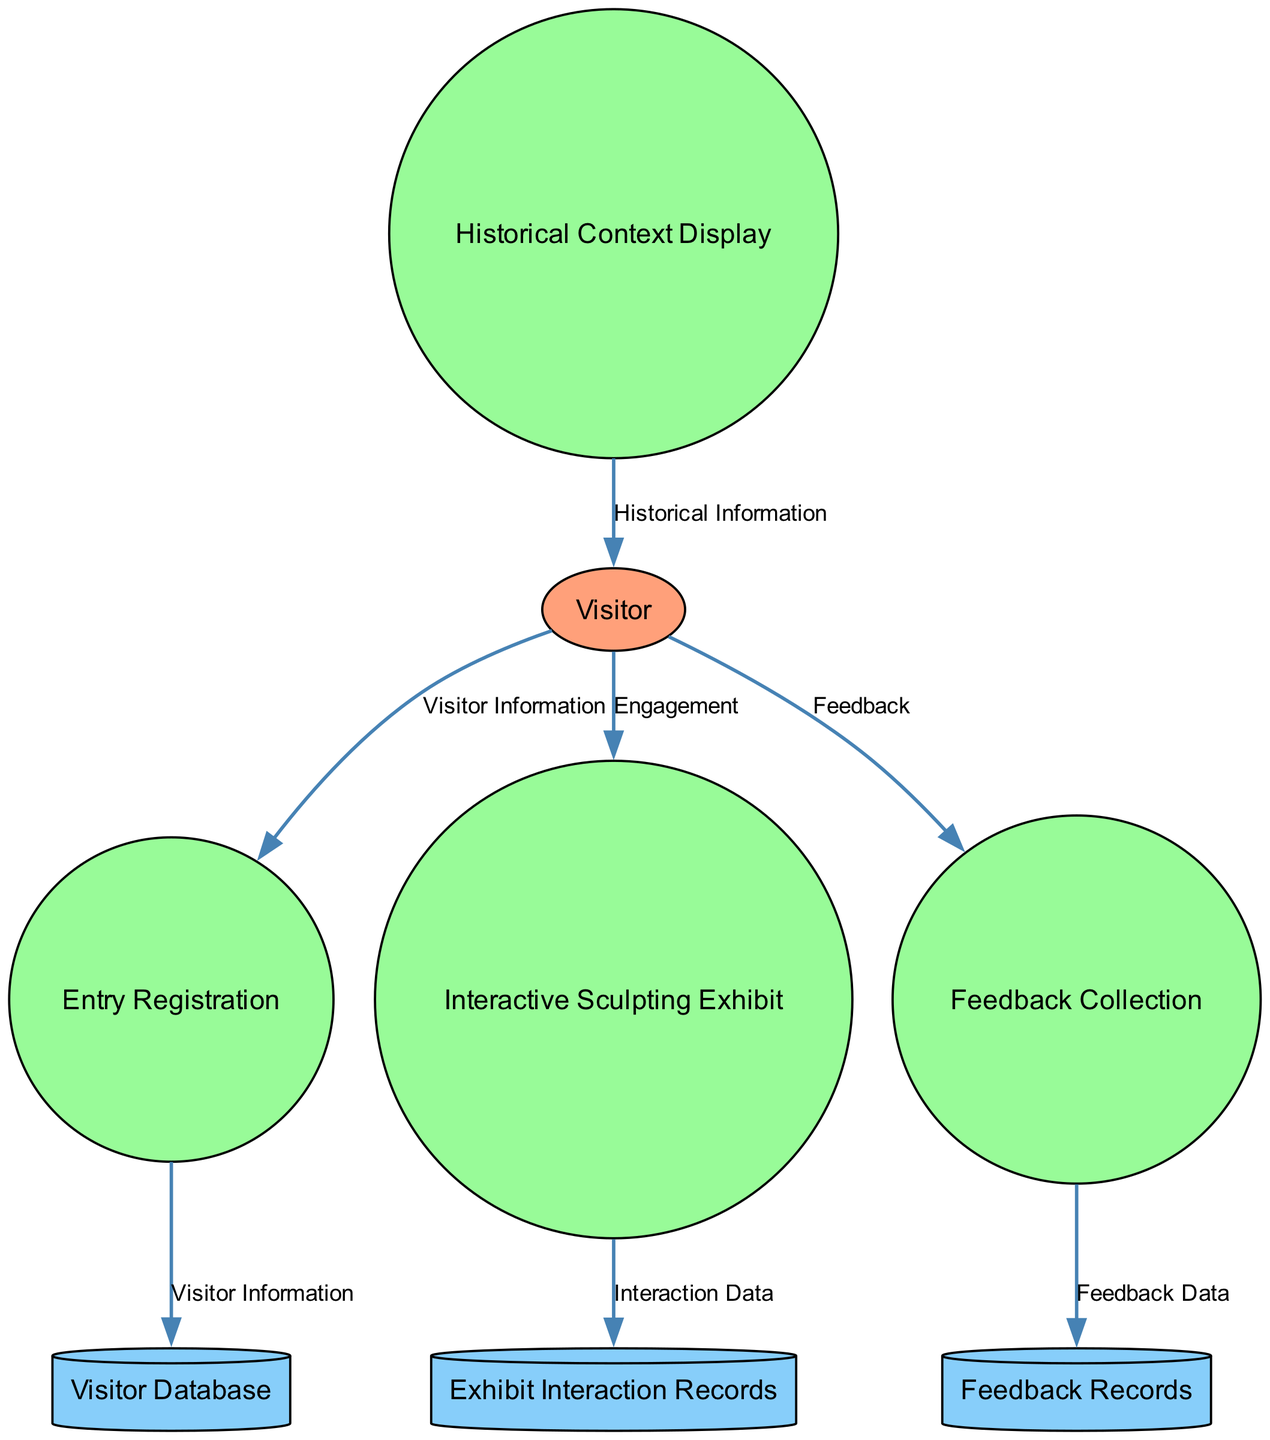What external entity is involved in this diagram? The diagram indicates "Visitor" as the external entity. It describes individuals who visit the museum for learning about ancient Greek sculptures and classical sculpting methods.
Answer: Visitor How many processes are depicted in this diagram? The diagram includes four processes: Entry Registration, Interactive Sculpting Exhibit, Historical Context Display, and Feedback Collection. Therefore, the total count of processes is four.
Answer: 4 What does the Interactive Sculpting Exhibit provide to visitors? The diagram shows that the Interactive Sculpting Exhibit allows visitors to engage in sculpting activities using virtual tools guided by classical methods.
Answer: Engagement From where does Feedback Data flow? According to the diagram, Feedback Data flows from Feedback Collection to Feedback Records, indicating that collected visitor feedback is stored in records.
Answer: Feedback Records Which data store contains visitor registration details? The Visitor Database is specified in the diagram as the data store for visitor registration details, including names, contact information, and ticket details.
Answer: Visitor Database What type of information does the Historical Context Display provide? The Historical Context Display provides Historical Information to visitors, offering context and background details about Greek sculptures and sculpting techniques.
Answer: Historical Information What flows from the Visitor to the Entry Registration process? The Visitor provides Visitor Information to the Entry Registration process, allowing the system to collect details for registration purposes.
Answer: Visitor Information How many data flows are represented in the diagram? The diagram outlines six distinct data flows connecting various entities and processes. This includes flows such as Visitor Information, Engagement, Feedback, and others.
Answer: 6 What type of exhibit enhances the visitor experience? The diagram specifically highlights the Interactive Sculpting Exhibit as the component that enhances the visitor experience through hands-on engagement with sculpting activities.
Answer: Interactive Sculpting Exhibit Which process gathers feedback from visitors? The Feedback Collection process is identified in the diagram as the one responsible for gathering feedback from visitors regarding their experiences and suggestions for improvements.
Answer: Feedback Collection 